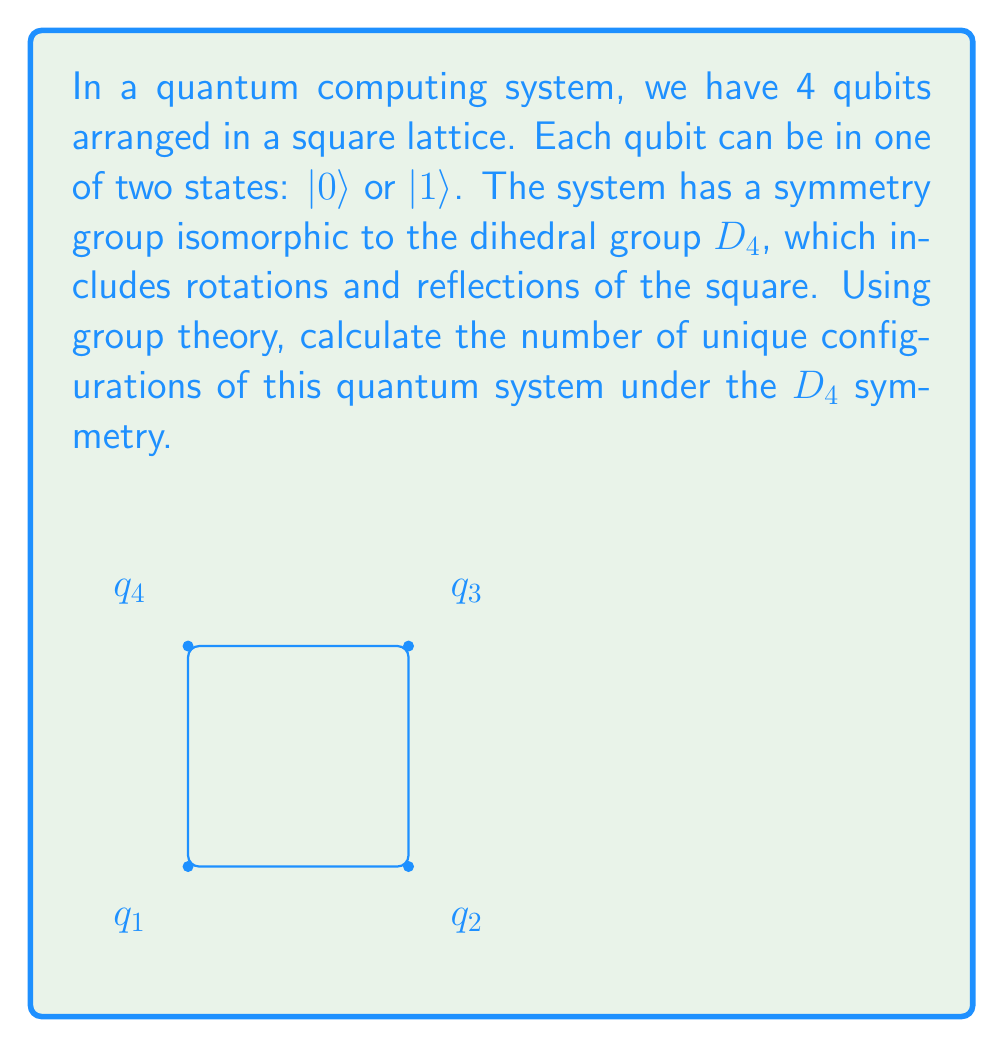Give your solution to this math problem. To solve this problem, we'll use Burnside's lemma from group theory. Let's proceed step-by-step:

1) The total number of possible configurations without considering symmetry is $2^4 = 16$, as each qubit can be in one of two states.

2) The dihedral group $D_4$ has 8 elements: the identity, 3 rotations (90°, 180°, 270°), 2 diagonal reflections, and 2 axial reflections.

3) Burnside's lemma states that the number of orbits (unique configurations) is:

   $$|X/G| = \frac{1}{|G|} \sum_{g \in G} |X^g|$$

   Where $|X/G|$ is the number of orbits, $|G|$ is the order of the group, and $|X^g|$ is the number of elements fixed by each group element $g$.

4) Let's count the fixed points for each group element:
   - Identity: fixes all 16 configurations
   - 90° and 270° rotations: fix only 2 configurations (all 0s or all 1s)
   - 180° rotation: fixes 4 configurations (all 0s, all 1s, alternating 0s and 1s in two ways)
   - 2 diagonal reflections: each fixes 4 configurations
   - 2 axial reflections: each fixes 4 configurations

5) Applying Burnside's lemma:

   $$|X/G| = \frac{1}{8}(16 + 2 + 2 + 4 + 4 + 4 + 4 + 4) = \frac{40}{8} = 5$$

Therefore, there are 5 unique configurations under the $D_4$ symmetry.
Answer: 5 unique configurations 